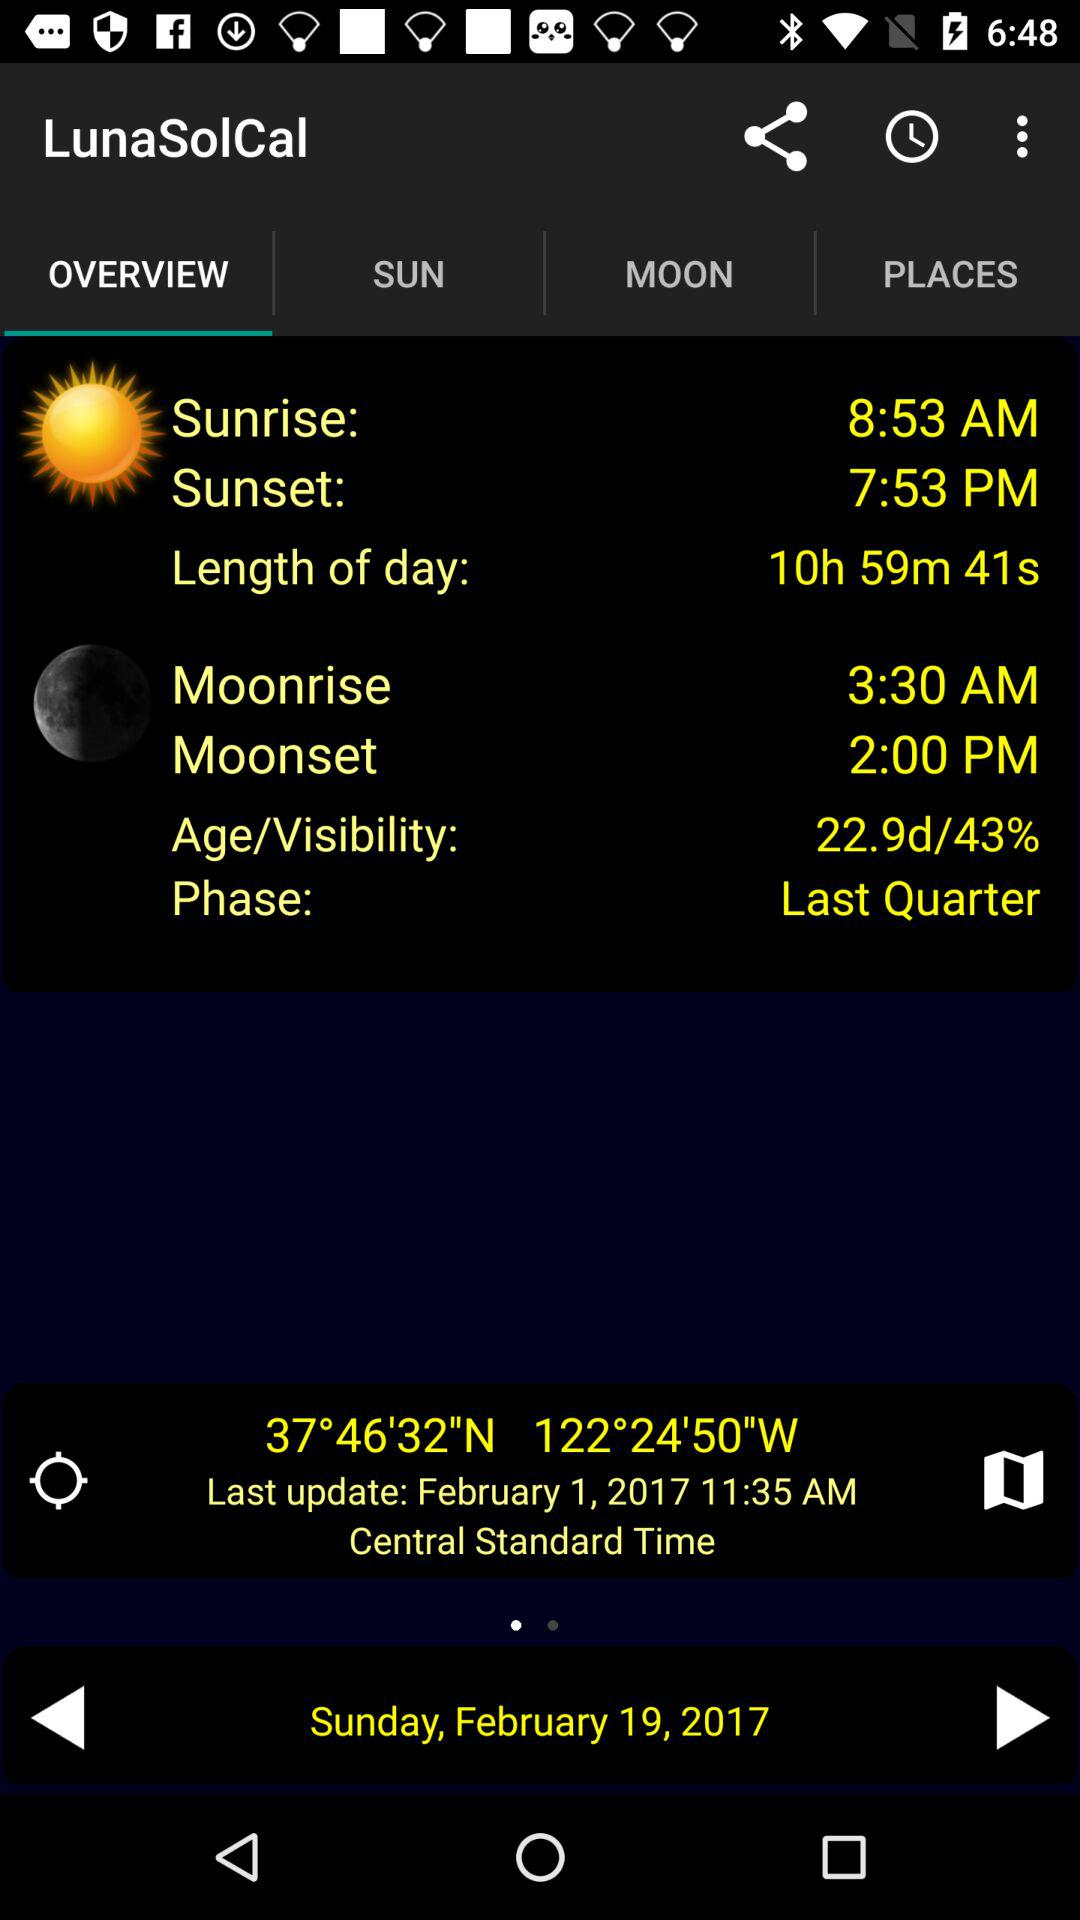What's the length of the day? The length of the day is 10 hours,59 minutes and 41 seconds. 